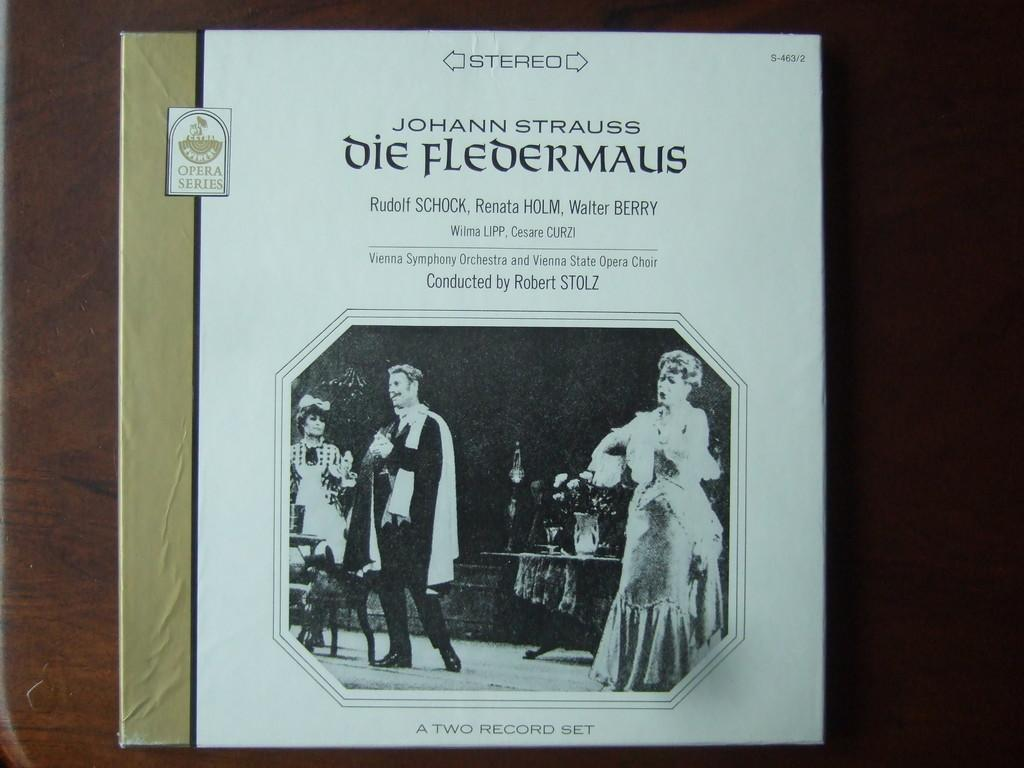<image>
Relay a brief, clear account of the picture shown. a record cover that says 'johann strauss die fledermaus' on it 